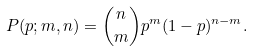Convert formula to latex. <formula><loc_0><loc_0><loc_500><loc_500>P ( p ; m , n ) = { n \choose m } p ^ { m } ( 1 - p ) ^ { n - m } .</formula> 